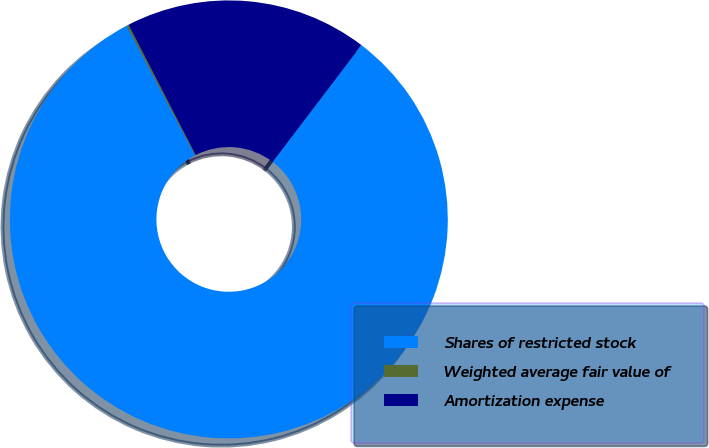<chart> <loc_0><loc_0><loc_500><loc_500><pie_chart><fcel>Shares of restricted stock<fcel>Weighted average fair value of<fcel>Amortization expense<nl><fcel>81.93%<fcel>0.16%<fcel>17.91%<nl></chart> 